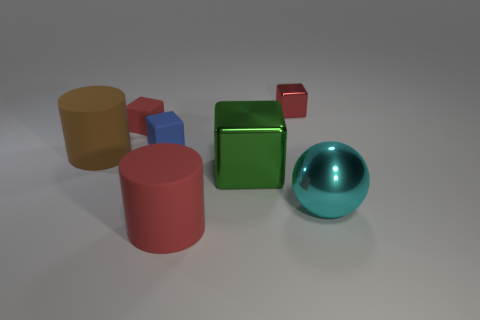Does the metal ball have the same color as the large rubber thing that is to the right of the large brown cylinder?
Provide a succinct answer. No. What number of purple things are either metallic balls or tiny matte objects?
Provide a succinct answer. 0. The brown object has what shape?
Provide a succinct answer. Cylinder. How many other things are the same shape as the tiny blue thing?
Make the answer very short. 3. The small thing that is right of the tiny blue thing is what color?
Provide a short and direct response. Red. Are the tiny blue thing and the large green block made of the same material?
Provide a succinct answer. No. What number of things are either rubber blocks or small red blocks that are right of the big red rubber cylinder?
Your answer should be compact. 3. What size is the matte cylinder that is the same color as the tiny metallic cube?
Make the answer very short. Large. The metal object that is right of the tiny red shiny object has what shape?
Your answer should be compact. Sphere. There is a big cylinder in front of the cyan metal thing; is it the same color as the large metal ball?
Your answer should be very brief. No. 